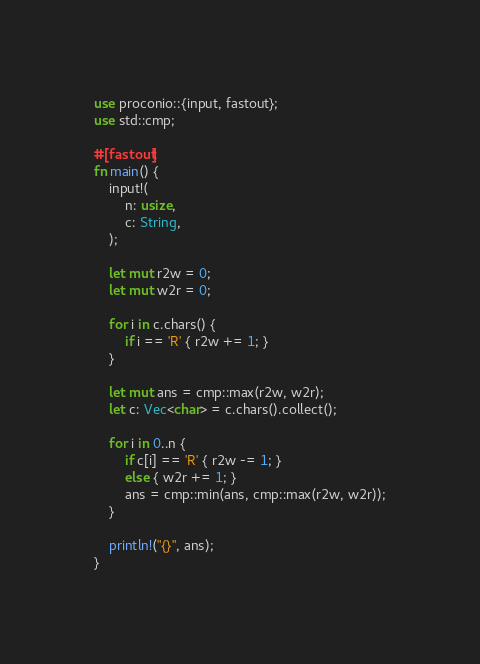Convert code to text. <code><loc_0><loc_0><loc_500><loc_500><_Rust_>use proconio::{input, fastout};
use std::cmp;

#[fastout]
fn main() {
    input!(
        n: usize,
        c: String,
    );

    let mut r2w = 0;
    let mut w2r = 0;

    for i in c.chars() {
        if i == 'R' { r2w += 1; }
    }

    let mut ans = cmp::max(r2w, w2r);
    let c: Vec<char> = c.chars().collect();

    for i in 0..n {
        if c[i] == 'R' { r2w -= 1; }
        else { w2r += 1; }
        ans = cmp::min(ans, cmp::max(r2w, w2r));
    }

    println!("{}", ans);
}</code> 